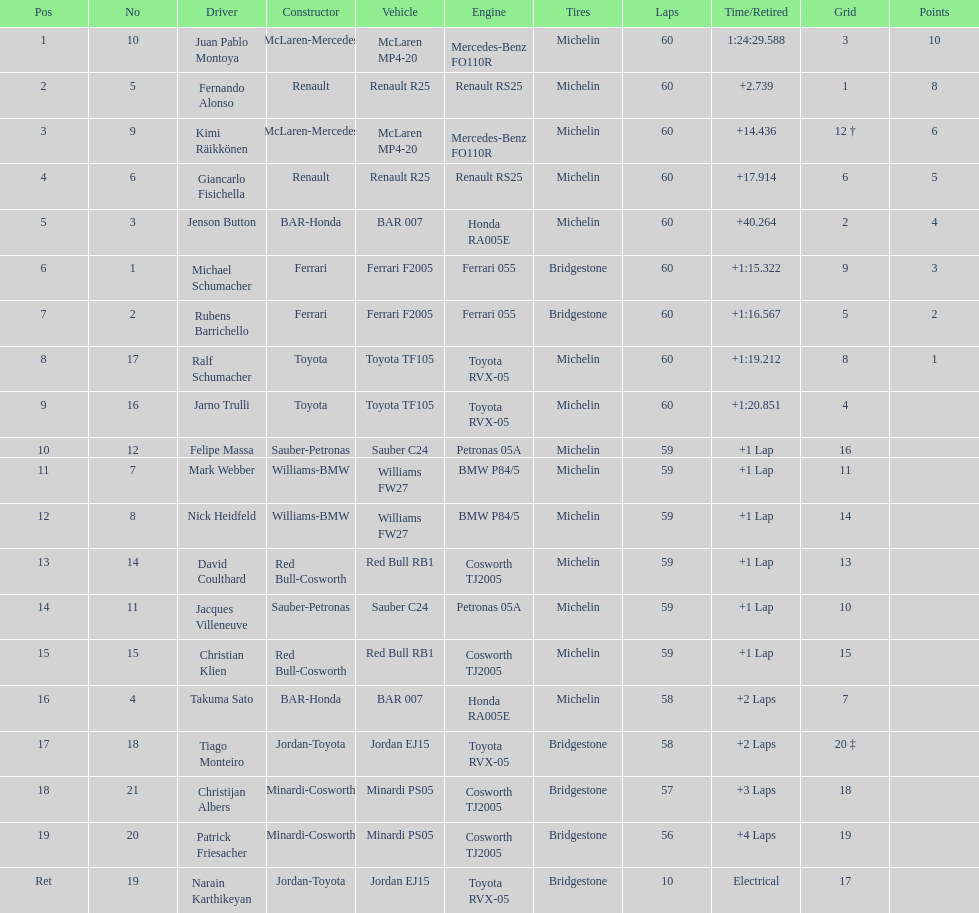Which driver came after giancarlo fisichella? Jenson Button. 